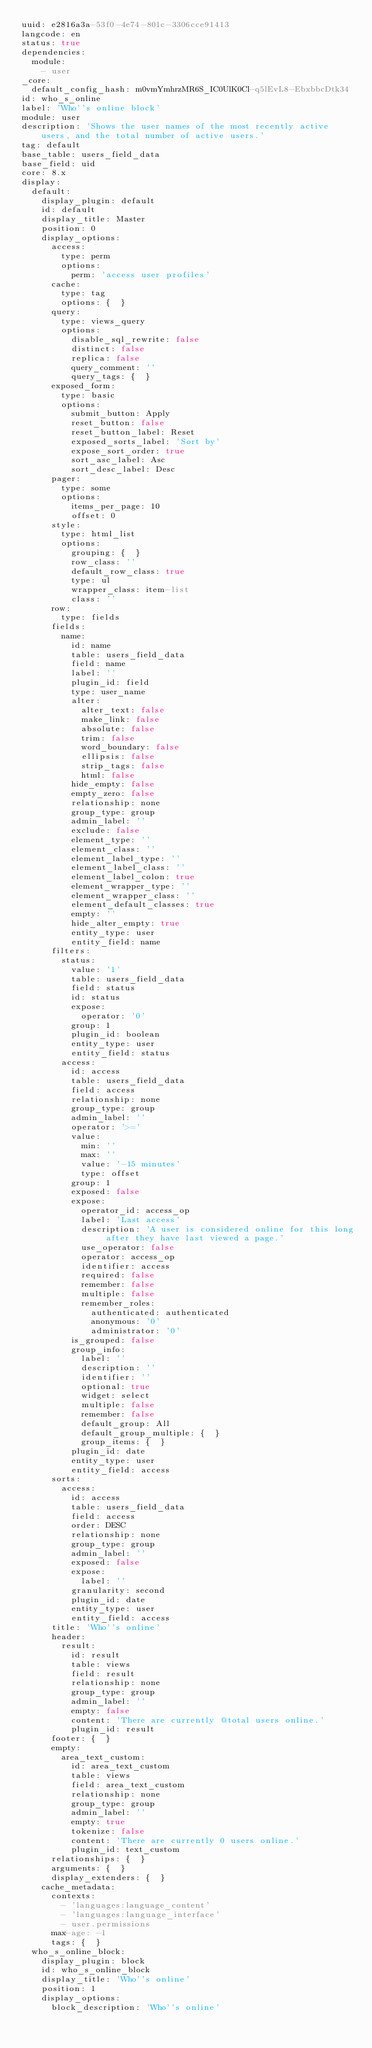<code> <loc_0><loc_0><loc_500><loc_500><_YAML_>uuid: e2816a3a-53f0-4e74-801c-3306cce91413
langcode: en
status: true
dependencies:
  module:
    - user
_core:
  default_config_hash: m0vmYmhrzMR6S_IC0UlK0Cl-q5lEvL8-EbxbbcDtk34
id: who_s_online
label: 'Who''s online block'
module: user
description: 'Shows the user names of the most recently active users, and the total number of active users.'
tag: default
base_table: users_field_data
base_field: uid
core: 8.x
display:
  default:
    display_plugin: default
    id: default
    display_title: Master
    position: 0
    display_options:
      access:
        type: perm
        options:
          perm: 'access user profiles'
      cache:
        type: tag
        options: {  }
      query:
        type: views_query
        options:
          disable_sql_rewrite: false
          distinct: false
          replica: false
          query_comment: ''
          query_tags: {  }
      exposed_form:
        type: basic
        options:
          submit_button: Apply
          reset_button: false
          reset_button_label: Reset
          exposed_sorts_label: 'Sort by'
          expose_sort_order: true
          sort_asc_label: Asc
          sort_desc_label: Desc
      pager:
        type: some
        options:
          items_per_page: 10
          offset: 0
      style:
        type: html_list
        options:
          grouping: {  }
          row_class: ''
          default_row_class: true
          type: ul
          wrapper_class: item-list
          class: ''
      row:
        type: fields
      fields:
        name:
          id: name
          table: users_field_data
          field: name
          label: ''
          plugin_id: field
          type: user_name
          alter:
            alter_text: false
            make_link: false
            absolute: false
            trim: false
            word_boundary: false
            ellipsis: false
            strip_tags: false
            html: false
          hide_empty: false
          empty_zero: false
          relationship: none
          group_type: group
          admin_label: ''
          exclude: false
          element_type: ''
          element_class: ''
          element_label_type: ''
          element_label_class: ''
          element_label_colon: true
          element_wrapper_type: ''
          element_wrapper_class: ''
          element_default_classes: true
          empty: ''
          hide_alter_empty: true
          entity_type: user
          entity_field: name
      filters:
        status:
          value: '1'
          table: users_field_data
          field: status
          id: status
          expose:
            operator: '0'
          group: 1
          plugin_id: boolean
          entity_type: user
          entity_field: status
        access:
          id: access
          table: users_field_data
          field: access
          relationship: none
          group_type: group
          admin_label: ''
          operator: '>='
          value:
            min: ''
            max: ''
            value: '-15 minutes'
            type: offset
          group: 1
          exposed: false
          expose:
            operator_id: access_op
            label: 'Last access'
            description: 'A user is considered online for this long after they have last viewed a page.'
            use_operator: false
            operator: access_op
            identifier: access
            required: false
            remember: false
            multiple: false
            remember_roles:
              authenticated: authenticated
              anonymous: '0'
              administrator: '0'
          is_grouped: false
          group_info:
            label: ''
            description: ''
            identifier: ''
            optional: true
            widget: select
            multiple: false
            remember: false
            default_group: All
            default_group_multiple: {  }
            group_items: {  }
          plugin_id: date
          entity_type: user
          entity_field: access
      sorts:
        access:
          id: access
          table: users_field_data
          field: access
          order: DESC
          relationship: none
          group_type: group
          admin_label: ''
          exposed: false
          expose:
            label: ''
          granularity: second
          plugin_id: date
          entity_type: user
          entity_field: access
      title: 'Who''s online'
      header:
        result:
          id: result
          table: views
          field: result
          relationship: none
          group_type: group
          admin_label: ''
          empty: false
          content: 'There are currently @total users online.'
          plugin_id: result
      footer: {  }
      empty:
        area_text_custom:
          id: area_text_custom
          table: views
          field: area_text_custom
          relationship: none
          group_type: group
          admin_label: ''
          empty: true
          tokenize: false
          content: 'There are currently 0 users online.'
          plugin_id: text_custom
      relationships: {  }
      arguments: {  }
      display_extenders: {  }
    cache_metadata:
      contexts:
        - 'languages:language_content'
        - 'languages:language_interface'
        - user.permissions
      max-age: -1
      tags: {  }
  who_s_online_block:
    display_plugin: block
    id: who_s_online_block
    display_title: 'Who''s online'
    position: 1
    display_options:
      block_description: 'Who''s online'</code> 